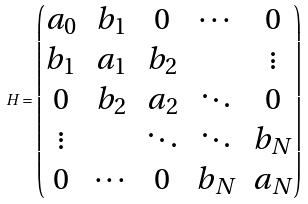Convert formula to latex. <formula><loc_0><loc_0><loc_500><loc_500>H = \begin{pmatrix} a _ { 0 } & b _ { 1 } & 0 & \cdots & 0 \\ b _ { 1 } & a _ { 1 } & b _ { 2 } & & \vdots \\ 0 & b _ { 2 } & a _ { 2 } & \ddots & 0 \\ \vdots & & \ddots & \ddots & b _ { N } \\ 0 & \cdots & 0 & b _ { N } & a _ { N } \\ \end{pmatrix}</formula> 